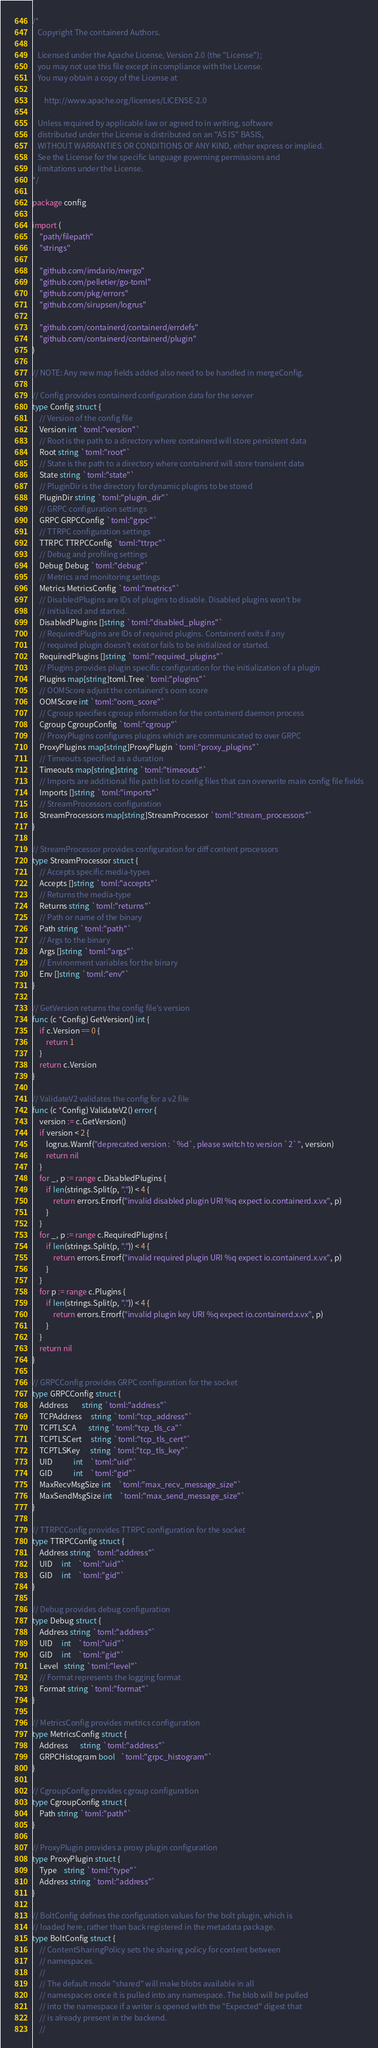Convert code to text. <code><loc_0><loc_0><loc_500><loc_500><_Go_>/*
   Copyright The containerd Authors.

   Licensed under the Apache License, Version 2.0 (the "License");
   you may not use this file except in compliance with the License.
   You may obtain a copy of the License at

       http://www.apache.org/licenses/LICENSE-2.0

   Unless required by applicable law or agreed to in writing, software
   distributed under the License is distributed on an "AS IS" BASIS,
   WITHOUT WARRANTIES OR CONDITIONS OF ANY KIND, either express or implied.
   See the License for the specific language governing permissions and
   limitations under the License.
*/

package config

import (
	"path/filepath"
	"strings"

	"github.com/imdario/mergo"
	"github.com/pelletier/go-toml"
	"github.com/pkg/errors"
	"github.com/sirupsen/logrus"

	"github.com/containerd/containerd/errdefs"
	"github.com/containerd/containerd/plugin"
)

// NOTE: Any new map fields added also need to be handled in mergeConfig.

// Config provides containerd configuration data for the server
type Config struct {
	// Version of the config file
	Version int `toml:"version"`
	// Root is the path to a directory where containerd will store persistent data
	Root string `toml:"root"`
	// State is the path to a directory where containerd will store transient data
	State string `toml:"state"`
	// PluginDir is the directory for dynamic plugins to be stored
	PluginDir string `toml:"plugin_dir"`
	// GRPC configuration settings
	GRPC GRPCConfig `toml:"grpc"`
	// TTRPC configuration settings
	TTRPC TTRPCConfig `toml:"ttrpc"`
	// Debug and profiling settings
	Debug Debug `toml:"debug"`
	// Metrics and monitoring settings
	Metrics MetricsConfig `toml:"metrics"`
	// DisabledPlugins are IDs of plugins to disable. Disabled plugins won't be
	// initialized and started.
	DisabledPlugins []string `toml:"disabled_plugins"`
	// RequiredPlugins are IDs of required plugins. Containerd exits if any
	// required plugin doesn't exist or fails to be initialized or started.
	RequiredPlugins []string `toml:"required_plugins"`
	// Plugins provides plugin specific configuration for the initialization of a plugin
	Plugins map[string]toml.Tree `toml:"plugins"`
	// OOMScore adjust the containerd's oom score
	OOMScore int `toml:"oom_score"`
	// Cgroup specifies cgroup information for the containerd daemon process
	Cgroup CgroupConfig `toml:"cgroup"`
	// ProxyPlugins configures plugins which are communicated to over GRPC
	ProxyPlugins map[string]ProxyPlugin `toml:"proxy_plugins"`
	// Timeouts specified as a duration
	Timeouts map[string]string `toml:"timeouts"`
	// Imports are additional file path list to config files that can overwrite main config file fields
	Imports []string `toml:"imports"`
	// StreamProcessors configuration
	StreamProcessors map[string]StreamProcessor `toml:"stream_processors"`
}

// StreamProcessor provides configuration for diff content processors
type StreamProcessor struct {
	// Accepts specific media-types
	Accepts []string `toml:"accepts"`
	// Returns the media-type
	Returns string `toml:"returns"`
	// Path or name of the binary
	Path string `toml:"path"`
	// Args to the binary
	Args []string `toml:"args"`
	// Environment variables for the binary
	Env []string `toml:"env"`
}

// GetVersion returns the config file's version
func (c *Config) GetVersion() int {
	if c.Version == 0 {
		return 1
	}
	return c.Version
}

// ValidateV2 validates the config for a v2 file
func (c *Config) ValidateV2() error {
	version := c.GetVersion()
	if version < 2 {
		logrus.Warnf("deprecated version : `%d`, please switch to version `2`", version)
		return nil
	}
	for _, p := range c.DisabledPlugins {
		if len(strings.Split(p, ".")) < 4 {
			return errors.Errorf("invalid disabled plugin URI %q expect io.containerd.x.vx", p)
		}
	}
	for _, p := range c.RequiredPlugins {
		if len(strings.Split(p, ".")) < 4 {
			return errors.Errorf("invalid required plugin URI %q expect io.containerd.x.vx", p)
		}
	}
	for p := range c.Plugins {
		if len(strings.Split(p, ".")) < 4 {
			return errors.Errorf("invalid plugin key URI %q expect io.containerd.x.vx", p)
		}
	}
	return nil
}

// GRPCConfig provides GRPC configuration for the socket
type GRPCConfig struct {
	Address        string `toml:"address"`
	TCPAddress     string `toml:"tcp_address"`
	TCPTLSCA       string `toml:"tcp_tls_ca"`
	TCPTLSCert     string `toml:"tcp_tls_cert"`
	TCPTLSKey      string `toml:"tcp_tls_key"`
	UID            int    `toml:"uid"`
	GID            int    `toml:"gid"`
	MaxRecvMsgSize int    `toml:"max_recv_message_size"`
	MaxSendMsgSize int    `toml:"max_send_message_size"`
}

// TTRPCConfig provides TTRPC configuration for the socket
type TTRPCConfig struct {
	Address string `toml:"address"`
	UID     int    `toml:"uid"`
	GID     int    `toml:"gid"`
}

// Debug provides debug configuration
type Debug struct {
	Address string `toml:"address"`
	UID     int    `toml:"uid"`
	GID     int    `toml:"gid"`
	Level   string `toml:"level"`
	// Format represents the logging format
	Format string `toml:"format"`
}

// MetricsConfig provides metrics configuration
type MetricsConfig struct {
	Address       string `toml:"address"`
	GRPCHistogram bool   `toml:"grpc_histogram"`
}

// CgroupConfig provides cgroup configuration
type CgroupConfig struct {
	Path string `toml:"path"`
}

// ProxyPlugin provides a proxy plugin configuration
type ProxyPlugin struct {
	Type    string `toml:"type"`
	Address string `toml:"address"`
}

// BoltConfig defines the configuration values for the bolt plugin, which is
// loaded here, rather than back registered in the metadata package.
type BoltConfig struct {
	// ContentSharingPolicy sets the sharing policy for content between
	// namespaces.
	//
	// The default mode "shared" will make blobs available in all
	// namespaces once it is pulled into any namespace. The blob will be pulled
	// into the namespace if a writer is opened with the "Expected" digest that
	// is already present in the backend.
	//</code> 